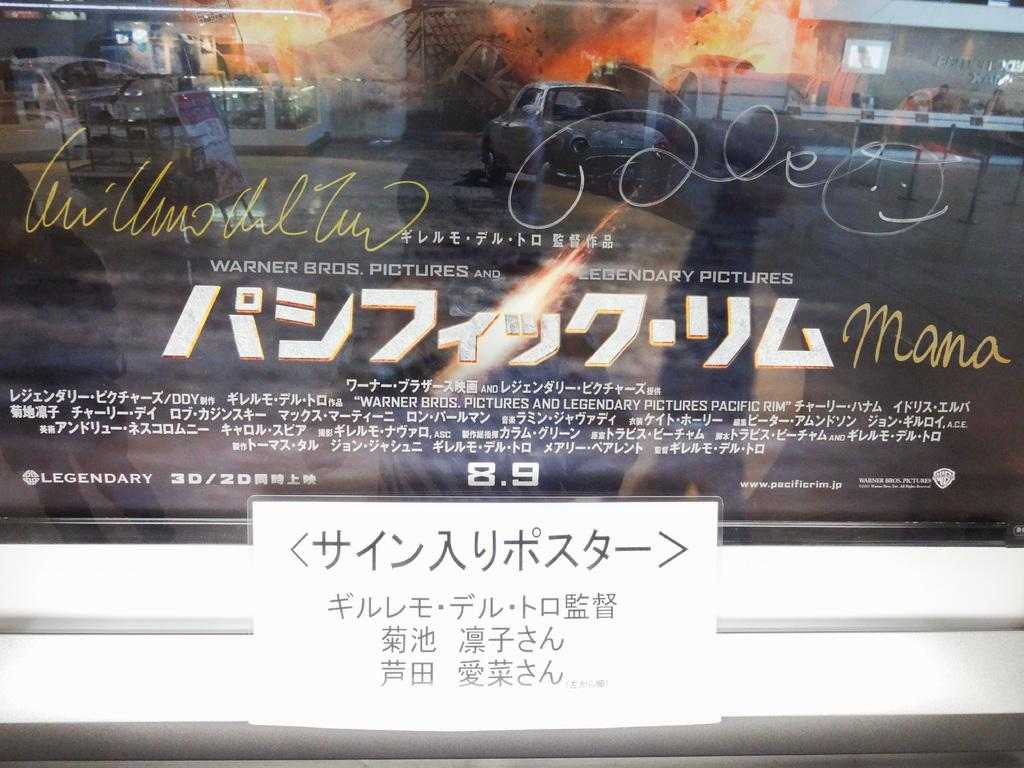<image>
Give a short and clear explanation of the subsequent image. A foreign movie poster with the numbers 8.9 in the bottom middle 